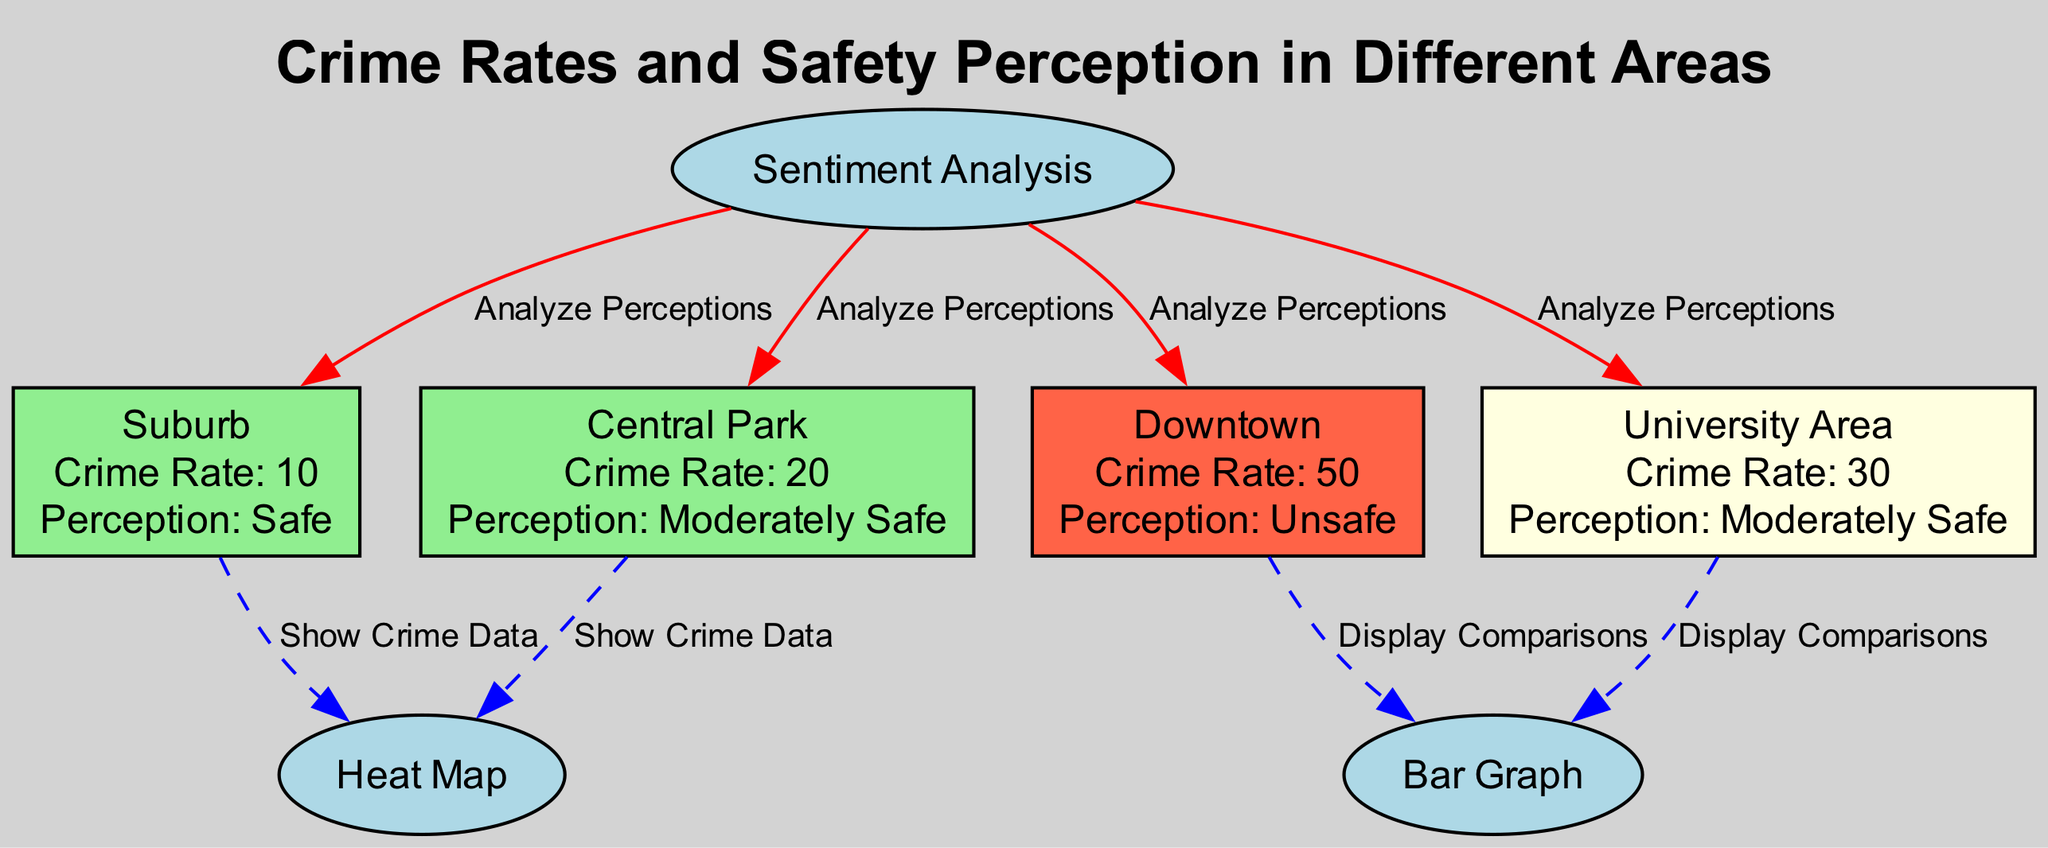What is the crime rate in Central Park? The crime rate for Central Park is stated directly in the node as 20.
Answer: 20 What is the safety perception of Downtown? Downtown's safety perception is labeled in the node as "Unsafe."
Answer: Unsafe How many locations are represented in the diagram? By counting the nodes labeled as locations, we find four: Central Park, Downtown, Suburb, and University Area.
Answer: 4 Which area has the lowest crime rate? Comparing the crime rates of all locations, Suburb has the lowest rate at 10.
Answer: Suburb What method is used to analyze perceptions in the diagram? The diagram indicates that "Sentiment Analysis" is the method applied to analyze perceptions for all locations.
Answer: Sentiment Analysis In which areas is the crime data shown using a heat map? The heat map displays crime data for Central Park and Suburb as indicated by the edges connecting these locations to the heat map node.
Answer: Central Park and Suburb What is the relationship between Downtown and the bar graph? The edge connecting Downtown to the bar graph indicates that the bar graph is used to display comparisons specific to Downtown.
Answer: Display Comparisons Which location has a crime rate higher than 30? Among the locations, Downtown has a crime rate of 50, which is higher than 30.
Answer: Downtown Which two locations have the same safety perception? Both Central Park and University Area have the safety perception labeled as "Moderately Safe," as shown in their respective nodes.
Answer: Central Park and University Area 